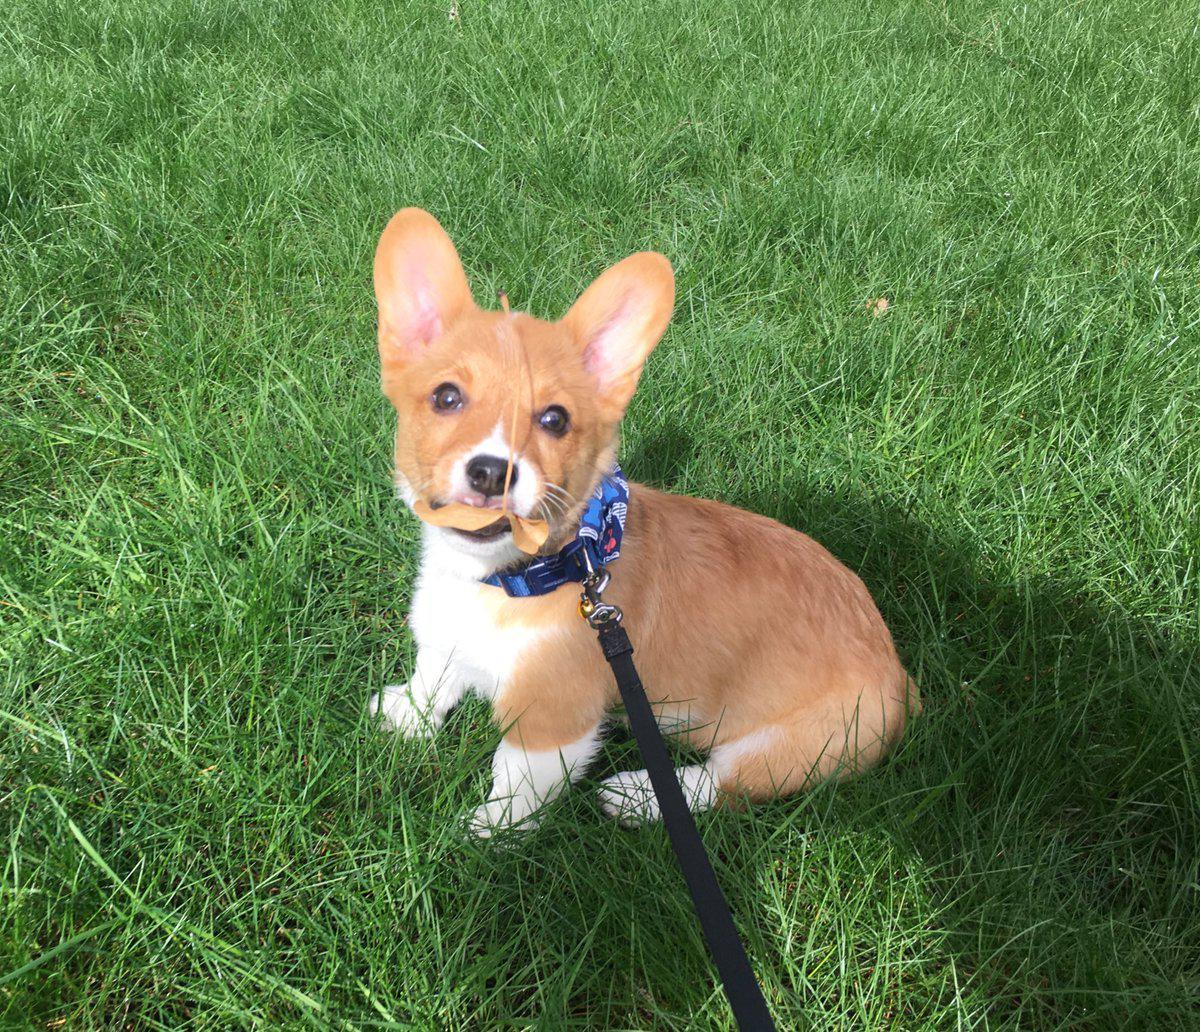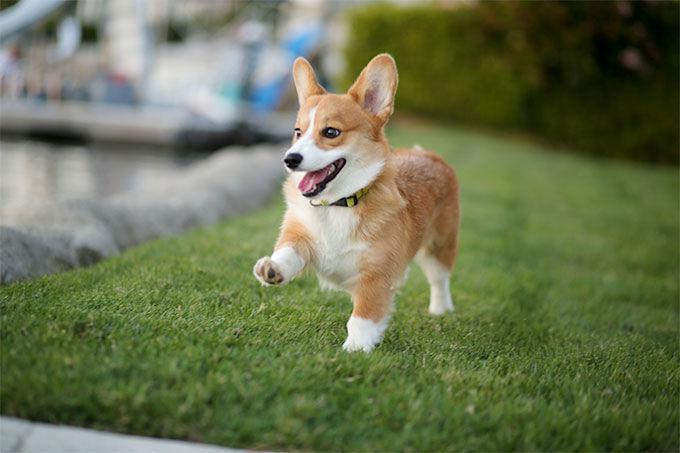The first image is the image on the left, the second image is the image on the right. Given the left and right images, does the statement "The dog in the left image has its tongue out." hold true? Answer yes or no. No. The first image is the image on the left, the second image is the image on the right. Considering the images on both sides, is "Each image contains one orange-and-white corgi dog, each of the depicted dogs has its face turned forward." valid? Answer yes or no. No. 